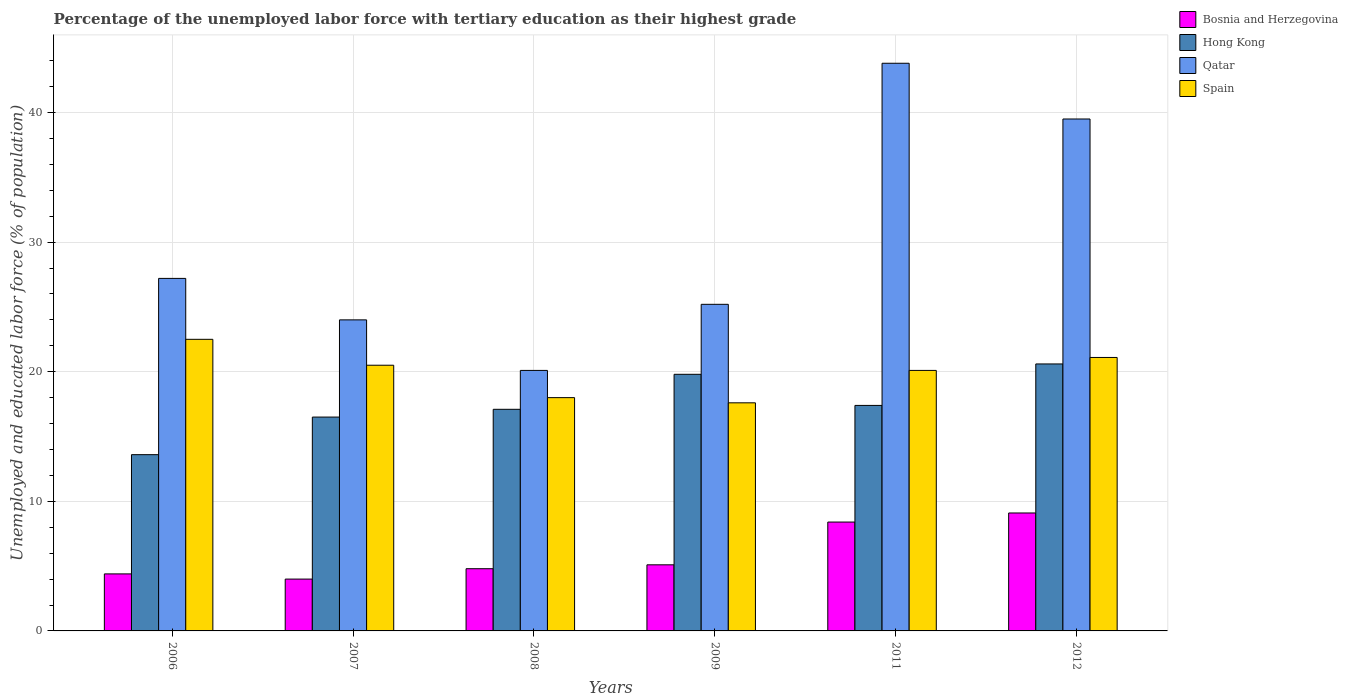How many different coloured bars are there?
Make the answer very short. 4. How many groups of bars are there?
Give a very brief answer. 6. Are the number of bars per tick equal to the number of legend labels?
Your answer should be very brief. Yes. What is the label of the 1st group of bars from the left?
Offer a terse response. 2006. In how many cases, is the number of bars for a given year not equal to the number of legend labels?
Ensure brevity in your answer.  0. What is the percentage of the unemployed labor force with tertiary education in Bosnia and Herzegovina in 2007?
Make the answer very short. 4. Across all years, what is the maximum percentage of the unemployed labor force with tertiary education in Bosnia and Herzegovina?
Ensure brevity in your answer.  9.1. Across all years, what is the minimum percentage of the unemployed labor force with tertiary education in Hong Kong?
Offer a terse response. 13.6. In which year was the percentage of the unemployed labor force with tertiary education in Hong Kong minimum?
Make the answer very short. 2006. What is the total percentage of the unemployed labor force with tertiary education in Qatar in the graph?
Ensure brevity in your answer.  179.8. What is the difference between the percentage of the unemployed labor force with tertiary education in Hong Kong in 2006 and that in 2008?
Your answer should be compact. -3.5. What is the difference between the percentage of the unemployed labor force with tertiary education in Spain in 2009 and the percentage of the unemployed labor force with tertiary education in Qatar in 2006?
Offer a very short reply. -9.6. What is the average percentage of the unemployed labor force with tertiary education in Bosnia and Herzegovina per year?
Your answer should be compact. 5.97. In the year 2012, what is the difference between the percentage of the unemployed labor force with tertiary education in Hong Kong and percentage of the unemployed labor force with tertiary education in Bosnia and Herzegovina?
Make the answer very short. 11.5. In how many years, is the percentage of the unemployed labor force with tertiary education in Qatar greater than 30 %?
Your answer should be compact. 2. What is the ratio of the percentage of the unemployed labor force with tertiary education in Bosnia and Herzegovina in 2006 to that in 2011?
Give a very brief answer. 0.52. Is the difference between the percentage of the unemployed labor force with tertiary education in Hong Kong in 2006 and 2007 greater than the difference between the percentage of the unemployed labor force with tertiary education in Bosnia and Herzegovina in 2006 and 2007?
Give a very brief answer. No. What is the difference between the highest and the second highest percentage of the unemployed labor force with tertiary education in Qatar?
Make the answer very short. 4.3. What is the difference between the highest and the lowest percentage of the unemployed labor force with tertiary education in Bosnia and Herzegovina?
Provide a succinct answer. 5.1. What does the 3rd bar from the left in 2012 represents?
Your answer should be very brief. Qatar. What does the 4th bar from the right in 2012 represents?
Ensure brevity in your answer.  Bosnia and Herzegovina. Is it the case that in every year, the sum of the percentage of the unemployed labor force with tertiary education in Bosnia and Herzegovina and percentage of the unemployed labor force with tertiary education in Qatar is greater than the percentage of the unemployed labor force with tertiary education in Spain?
Make the answer very short. Yes. Are all the bars in the graph horizontal?
Make the answer very short. No. How many years are there in the graph?
Offer a very short reply. 6. What is the difference between two consecutive major ticks on the Y-axis?
Ensure brevity in your answer.  10. Are the values on the major ticks of Y-axis written in scientific E-notation?
Give a very brief answer. No. Does the graph contain any zero values?
Your answer should be very brief. No. Does the graph contain grids?
Offer a very short reply. Yes. What is the title of the graph?
Offer a terse response. Percentage of the unemployed labor force with tertiary education as their highest grade. Does "Belarus" appear as one of the legend labels in the graph?
Your answer should be very brief. No. What is the label or title of the X-axis?
Keep it short and to the point. Years. What is the label or title of the Y-axis?
Your answer should be compact. Unemployed and educated labor force (% of population). What is the Unemployed and educated labor force (% of population) of Bosnia and Herzegovina in 2006?
Your answer should be compact. 4.4. What is the Unemployed and educated labor force (% of population) of Hong Kong in 2006?
Provide a short and direct response. 13.6. What is the Unemployed and educated labor force (% of population) of Qatar in 2006?
Offer a terse response. 27.2. What is the Unemployed and educated labor force (% of population) of Spain in 2006?
Your answer should be very brief. 22.5. What is the Unemployed and educated labor force (% of population) of Qatar in 2007?
Give a very brief answer. 24. What is the Unemployed and educated labor force (% of population) of Spain in 2007?
Keep it short and to the point. 20.5. What is the Unemployed and educated labor force (% of population) in Bosnia and Herzegovina in 2008?
Ensure brevity in your answer.  4.8. What is the Unemployed and educated labor force (% of population) of Hong Kong in 2008?
Keep it short and to the point. 17.1. What is the Unemployed and educated labor force (% of population) in Qatar in 2008?
Provide a short and direct response. 20.1. What is the Unemployed and educated labor force (% of population) of Spain in 2008?
Provide a short and direct response. 18. What is the Unemployed and educated labor force (% of population) of Bosnia and Herzegovina in 2009?
Give a very brief answer. 5.1. What is the Unemployed and educated labor force (% of population) of Hong Kong in 2009?
Your answer should be compact. 19.8. What is the Unemployed and educated labor force (% of population) of Qatar in 2009?
Ensure brevity in your answer.  25.2. What is the Unemployed and educated labor force (% of population) of Spain in 2009?
Provide a succinct answer. 17.6. What is the Unemployed and educated labor force (% of population) in Bosnia and Herzegovina in 2011?
Ensure brevity in your answer.  8.4. What is the Unemployed and educated labor force (% of population) of Hong Kong in 2011?
Provide a succinct answer. 17.4. What is the Unemployed and educated labor force (% of population) in Qatar in 2011?
Your answer should be very brief. 43.8. What is the Unemployed and educated labor force (% of population) of Spain in 2011?
Offer a terse response. 20.1. What is the Unemployed and educated labor force (% of population) of Bosnia and Herzegovina in 2012?
Your response must be concise. 9.1. What is the Unemployed and educated labor force (% of population) in Hong Kong in 2012?
Provide a short and direct response. 20.6. What is the Unemployed and educated labor force (% of population) of Qatar in 2012?
Provide a succinct answer. 39.5. What is the Unemployed and educated labor force (% of population) in Spain in 2012?
Offer a very short reply. 21.1. Across all years, what is the maximum Unemployed and educated labor force (% of population) of Bosnia and Herzegovina?
Your answer should be very brief. 9.1. Across all years, what is the maximum Unemployed and educated labor force (% of population) of Hong Kong?
Your answer should be compact. 20.6. Across all years, what is the maximum Unemployed and educated labor force (% of population) of Qatar?
Make the answer very short. 43.8. Across all years, what is the maximum Unemployed and educated labor force (% of population) in Spain?
Give a very brief answer. 22.5. Across all years, what is the minimum Unemployed and educated labor force (% of population) of Bosnia and Herzegovina?
Provide a succinct answer. 4. Across all years, what is the minimum Unemployed and educated labor force (% of population) of Hong Kong?
Give a very brief answer. 13.6. Across all years, what is the minimum Unemployed and educated labor force (% of population) of Qatar?
Provide a short and direct response. 20.1. Across all years, what is the minimum Unemployed and educated labor force (% of population) of Spain?
Give a very brief answer. 17.6. What is the total Unemployed and educated labor force (% of population) in Bosnia and Herzegovina in the graph?
Give a very brief answer. 35.8. What is the total Unemployed and educated labor force (% of population) in Hong Kong in the graph?
Your answer should be very brief. 105. What is the total Unemployed and educated labor force (% of population) of Qatar in the graph?
Offer a very short reply. 179.8. What is the total Unemployed and educated labor force (% of population) in Spain in the graph?
Provide a succinct answer. 119.8. What is the difference between the Unemployed and educated labor force (% of population) in Qatar in 2006 and that in 2007?
Make the answer very short. 3.2. What is the difference between the Unemployed and educated labor force (% of population) in Spain in 2006 and that in 2007?
Ensure brevity in your answer.  2. What is the difference between the Unemployed and educated labor force (% of population) of Bosnia and Herzegovina in 2006 and that in 2008?
Provide a short and direct response. -0.4. What is the difference between the Unemployed and educated labor force (% of population) of Bosnia and Herzegovina in 2006 and that in 2011?
Your answer should be compact. -4. What is the difference between the Unemployed and educated labor force (% of population) in Qatar in 2006 and that in 2011?
Provide a succinct answer. -16.6. What is the difference between the Unemployed and educated labor force (% of population) in Hong Kong in 2006 and that in 2012?
Offer a very short reply. -7. What is the difference between the Unemployed and educated labor force (% of population) in Qatar in 2006 and that in 2012?
Your answer should be very brief. -12.3. What is the difference between the Unemployed and educated labor force (% of population) in Spain in 2006 and that in 2012?
Your answer should be compact. 1.4. What is the difference between the Unemployed and educated labor force (% of population) in Spain in 2007 and that in 2008?
Your answer should be compact. 2.5. What is the difference between the Unemployed and educated labor force (% of population) of Bosnia and Herzegovina in 2007 and that in 2009?
Provide a succinct answer. -1.1. What is the difference between the Unemployed and educated labor force (% of population) in Hong Kong in 2007 and that in 2009?
Give a very brief answer. -3.3. What is the difference between the Unemployed and educated labor force (% of population) in Qatar in 2007 and that in 2009?
Provide a succinct answer. -1.2. What is the difference between the Unemployed and educated labor force (% of population) of Spain in 2007 and that in 2009?
Your response must be concise. 2.9. What is the difference between the Unemployed and educated labor force (% of population) of Qatar in 2007 and that in 2011?
Your response must be concise. -19.8. What is the difference between the Unemployed and educated labor force (% of population) of Spain in 2007 and that in 2011?
Your answer should be very brief. 0.4. What is the difference between the Unemployed and educated labor force (% of population) in Bosnia and Herzegovina in 2007 and that in 2012?
Provide a short and direct response. -5.1. What is the difference between the Unemployed and educated labor force (% of population) in Hong Kong in 2007 and that in 2012?
Give a very brief answer. -4.1. What is the difference between the Unemployed and educated labor force (% of population) in Qatar in 2007 and that in 2012?
Your answer should be compact. -15.5. What is the difference between the Unemployed and educated labor force (% of population) of Bosnia and Herzegovina in 2008 and that in 2009?
Your answer should be very brief. -0.3. What is the difference between the Unemployed and educated labor force (% of population) in Hong Kong in 2008 and that in 2009?
Your response must be concise. -2.7. What is the difference between the Unemployed and educated labor force (% of population) of Hong Kong in 2008 and that in 2011?
Give a very brief answer. -0.3. What is the difference between the Unemployed and educated labor force (% of population) in Qatar in 2008 and that in 2011?
Your response must be concise. -23.7. What is the difference between the Unemployed and educated labor force (% of population) in Bosnia and Herzegovina in 2008 and that in 2012?
Give a very brief answer. -4.3. What is the difference between the Unemployed and educated labor force (% of population) in Hong Kong in 2008 and that in 2012?
Make the answer very short. -3.5. What is the difference between the Unemployed and educated labor force (% of population) of Qatar in 2008 and that in 2012?
Your answer should be compact. -19.4. What is the difference between the Unemployed and educated labor force (% of population) of Spain in 2008 and that in 2012?
Ensure brevity in your answer.  -3.1. What is the difference between the Unemployed and educated labor force (% of population) of Qatar in 2009 and that in 2011?
Provide a succinct answer. -18.6. What is the difference between the Unemployed and educated labor force (% of population) of Bosnia and Herzegovina in 2009 and that in 2012?
Give a very brief answer. -4. What is the difference between the Unemployed and educated labor force (% of population) in Hong Kong in 2009 and that in 2012?
Offer a terse response. -0.8. What is the difference between the Unemployed and educated labor force (% of population) in Qatar in 2009 and that in 2012?
Offer a very short reply. -14.3. What is the difference between the Unemployed and educated labor force (% of population) of Hong Kong in 2011 and that in 2012?
Keep it short and to the point. -3.2. What is the difference between the Unemployed and educated labor force (% of population) of Qatar in 2011 and that in 2012?
Make the answer very short. 4.3. What is the difference between the Unemployed and educated labor force (% of population) in Spain in 2011 and that in 2012?
Your response must be concise. -1. What is the difference between the Unemployed and educated labor force (% of population) of Bosnia and Herzegovina in 2006 and the Unemployed and educated labor force (% of population) of Hong Kong in 2007?
Offer a terse response. -12.1. What is the difference between the Unemployed and educated labor force (% of population) in Bosnia and Herzegovina in 2006 and the Unemployed and educated labor force (% of population) in Qatar in 2007?
Ensure brevity in your answer.  -19.6. What is the difference between the Unemployed and educated labor force (% of population) of Bosnia and Herzegovina in 2006 and the Unemployed and educated labor force (% of population) of Spain in 2007?
Your answer should be compact. -16.1. What is the difference between the Unemployed and educated labor force (% of population) of Hong Kong in 2006 and the Unemployed and educated labor force (% of population) of Qatar in 2007?
Your answer should be very brief. -10.4. What is the difference between the Unemployed and educated labor force (% of population) of Hong Kong in 2006 and the Unemployed and educated labor force (% of population) of Spain in 2007?
Ensure brevity in your answer.  -6.9. What is the difference between the Unemployed and educated labor force (% of population) in Qatar in 2006 and the Unemployed and educated labor force (% of population) in Spain in 2007?
Offer a very short reply. 6.7. What is the difference between the Unemployed and educated labor force (% of population) in Bosnia and Herzegovina in 2006 and the Unemployed and educated labor force (% of population) in Qatar in 2008?
Offer a very short reply. -15.7. What is the difference between the Unemployed and educated labor force (% of population) in Bosnia and Herzegovina in 2006 and the Unemployed and educated labor force (% of population) in Hong Kong in 2009?
Provide a succinct answer. -15.4. What is the difference between the Unemployed and educated labor force (% of population) in Bosnia and Herzegovina in 2006 and the Unemployed and educated labor force (% of population) in Qatar in 2009?
Provide a short and direct response. -20.8. What is the difference between the Unemployed and educated labor force (% of population) of Hong Kong in 2006 and the Unemployed and educated labor force (% of population) of Qatar in 2009?
Your answer should be very brief. -11.6. What is the difference between the Unemployed and educated labor force (% of population) in Qatar in 2006 and the Unemployed and educated labor force (% of population) in Spain in 2009?
Provide a succinct answer. 9.6. What is the difference between the Unemployed and educated labor force (% of population) in Bosnia and Herzegovina in 2006 and the Unemployed and educated labor force (% of population) in Qatar in 2011?
Keep it short and to the point. -39.4. What is the difference between the Unemployed and educated labor force (% of population) in Bosnia and Herzegovina in 2006 and the Unemployed and educated labor force (% of population) in Spain in 2011?
Your response must be concise. -15.7. What is the difference between the Unemployed and educated labor force (% of population) in Hong Kong in 2006 and the Unemployed and educated labor force (% of population) in Qatar in 2011?
Provide a short and direct response. -30.2. What is the difference between the Unemployed and educated labor force (% of population) in Hong Kong in 2006 and the Unemployed and educated labor force (% of population) in Spain in 2011?
Ensure brevity in your answer.  -6.5. What is the difference between the Unemployed and educated labor force (% of population) of Bosnia and Herzegovina in 2006 and the Unemployed and educated labor force (% of population) of Hong Kong in 2012?
Ensure brevity in your answer.  -16.2. What is the difference between the Unemployed and educated labor force (% of population) of Bosnia and Herzegovina in 2006 and the Unemployed and educated labor force (% of population) of Qatar in 2012?
Offer a terse response. -35.1. What is the difference between the Unemployed and educated labor force (% of population) in Bosnia and Herzegovina in 2006 and the Unemployed and educated labor force (% of population) in Spain in 2012?
Offer a terse response. -16.7. What is the difference between the Unemployed and educated labor force (% of population) in Hong Kong in 2006 and the Unemployed and educated labor force (% of population) in Qatar in 2012?
Give a very brief answer. -25.9. What is the difference between the Unemployed and educated labor force (% of population) in Hong Kong in 2006 and the Unemployed and educated labor force (% of population) in Spain in 2012?
Provide a short and direct response. -7.5. What is the difference between the Unemployed and educated labor force (% of population) in Bosnia and Herzegovina in 2007 and the Unemployed and educated labor force (% of population) in Hong Kong in 2008?
Give a very brief answer. -13.1. What is the difference between the Unemployed and educated labor force (% of population) of Bosnia and Herzegovina in 2007 and the Unemployed and educated labor force (% of population) of Qatar in 2008?
Ensure brevity in your answer.  -16.1. What is the difference between the Unemployed and educated labor force (% of population) of Bosnia and Herzegovina in 2007 and the Unemployed and educated labor force (% of population) of Spain in 2008?
Keep it short and to the point. -14. What is the difference between the Unemployed and educated labor force (% of population) of Hong Kong in 2007 and the Unemployed and educated labor force (% of population) of Spain in 2008?
Your answer should be compact. -1.5. What is the difference between the Unemployed and educated labor force (% of population) of Bosnia and Herzegovina in 2007 and the Unemployed and educated labor force (% of population) of Hong Kong in 2009?
Your response must be concise. -15.8. What is the difference between the Unemployed and educated labor force (% of population) of Bosnia and Herzegovina in 2007 and the Unemployed and educated labor force (% of population) of Qatar in 2009?
Provide a short and direct response. -21.2. What is the difference between the Unemployed and educated labor force (% of population) in Bosnia and Herzegovina in 2007 and the Unemployed and educated labor force (% of population) in Spain in 2009?
Keep it short and to the point. -13.6. What is the difference between the Unemployed and educated labor force (% of population) in Hong Kong in 2007 and the Unemployed and educated labor force (% of population) in Spain in 2009?
Your response must be concise. -1.1. What is the difference between the Unemployed and educated labor force (% of population) of Qatar in 2007 and the Unemployed and educated labor force (% of population) of Spain in 2009?
Provide a succinct answer. 6.4. What is the difference between the Unemployed and educated labor force (% of population) of Bosnia and Herzegovina in 2007 and the Unemployed and educated labor force (% of population) of Hong Kong in 2011?
Your answer should be compact. -13.4. What is the difference between the Unemployed and educated labor force (% of population) of Bosnia and Herzegovina in 2007 and the Unemployed and educated labor force (% of population) of Qatar in 2011?
Provide a short and direct response. -39.8. What is the difference between the Unemployed and educated labor force (% of population) of Bosnia and Herzegovina in 2007 and the Unemployed and educated labor force (% of population) of Spain in 2011?
Provide a short and direct response. -16.1. What is the difference between the Unemployed and educated labor force (% of population) in Hong Kong in 2007 and the Unemployed and educated labor force (% of population) in Qatar in 2011?
Offer a very short reply. -27.3. What is the difference between the Unemployed and educated labor force (% of population) of Qatar in 2007 and the Unemployed and educated labor force (% of population) of Spain in 2011?
Keep it short and to the point. 3.9. What is the difference between the Unemployed and educated labor force (% of population) of Bosnia and Herzegovina in 2007 and the Unemployed and educated labor force (% of population) of Hong Kong in 2012?
Your response must be concise. -16.6. What is the difference between the Unemployed and educated labor force (% of population) in Bosnia and Herzegovina in 2007 and the Unemployed and educated labor force (% of population) in Qatar in 2012?
Give a very brief answer. -35.5. What is the difference between the Unemployed and educated labor force (% of population) of Bosnia and Herzegovina in 2007 and the Unemployed and educated labor force (% of population) of Spain in 2012?
Make the answer very short. -17.1. What is the difference between the Unemployed and educated labor force (% of population) in Hong Kong in 2007 and the Unemployed and educated labor force (% of population) in Qatar in 2012?
Your response must be concise. -23. What is the difference between the Unemployed and educated labor force (% of population) of Hong Kong in 2007 and the Unemployed and educated labor force (% of population) of Spain in 2012?
Keep it short and to the point. -4.6. What is the difference between the Unemployed and educated labor force (% of population) of Qatar in 2007 and the Unemployed and educated labor force (% of population) of Spain in 2012?
Offer a very short reply. 2.9. What is the difference between the Unemployed and educated labor force (% of population) in Bosnia and Herzegovina in 2008 and the Unemployed and educated labor force (% of population) in Qatar in 2009?
Provide a short and direct response. -20.4. What is the difference between the Unemployed and educated labor force (% of population) in Hong Kong in 2008 and the Unemployed and educated labor force (% of population) in Qatar in 2009?
Offer a very short reply. -8.1. What is the difference between the Unemployed and educated labor force (% of population) in Bosnia and Herzegovina in 2008 and the Unemployed and educated labor force (% of population) in Qatar in 2011?
Your response must be concise. -39. What is the difference between the Unemployed and educated labor force (% of population) of Bosnia and Herzegovina in 2008 and the Unemployed and educated labor force (% of population) of Spain in 2011?
Your response must be concise. -15.3. What is the difference between the Unemployed and educated labor force (% of population) in Hong Kong in 2008 and the Unemployed and educated labor force (% of population) in Qatar in 2011?
Make the answer very short. -26.7. What is the difference between the Unemployed and educated labor force (% of population) of Qatar in 2008 and the Unemployed and educated labor force (% of population) of Spain in 2011?
Your response must be concise. 0. What is the difference between the Unemployed and educated labor force (% of population) of Bosnia and Herzegovina in 2008 and the Unemployed and educated labor force (% of population) of Hong Kong in 2012?
Keep it short and to the point. -15.8. What is the difference between the Unemployed and educated labor force (% of population) in Bosnia and Herzegovina in 2008 and the Unemployed and educated labor force (% of population) in Qatar in 2012?
Your response must be concise. -34.7. What is the difference between the Unemployed and educated labor force (% of population) in Bosnia and Herzegovina in 2008 and the Unemployed and educated labor force (% of population) in Spain in 2012?
Your response must be concise. -16.3. What is the difference between the Unemployed and educated labor force (% of population) in Hong Kong in 2008 and the Unemployed and educated labor force (% of population) in Qatar in 2012?
Offer a terse response. -22.4. What is the difference between the Unemployed and educated labor force (% of population) of Qatar in 2008 and the Unemployed and educated labor force (% of population) of Spain in 2012?
Give a very brief answer. -1. What is the difference between the Unemployed and educated labor force (% of population) in Bosnia and Herzegovina in 2009 and the Unemployed and educated labor force (% of population) in Hong Kong in 2011?
Provide a succinct answer. -12.3. What is the difference between the Unemployed and educated labor force (% of population) in Bosnia and Herzegovina in 2009 and the Unemployed and educated labor force (% of population) in Qatar in 2011?
Offer a very short reply. -38.7. What is the difference between the Unemployed and educated labor force (% of population) of Bosnia and Herzegovina in 2009 and the Unemployed and educated labor force (% of population) of Spain in 2011?
Keep it short and to the point. -15. What is the difference between the Unemployed and educated labor force (% of population) in Qatar in 2009 and the Unemployed and educated labor force (% of population) in Spain in 2011?
Make the answer very short. 5.1. What is the difference between the Unemployed and educated labor force (% of population) of Bosnia and Herzegovina in 2009 and the Unemployed and educated labor force (% of population) of Hong Kong in 2012?
Offer a terse response. -15.5. What is the difference between the Unemployed and educated labor force (% of population) of Bosnia and Herzegovina in 2009 and the Unemployed and educated labor force (% of population) of Qatar in 2012?
Your response must be concise. -34.4. What is the difference between the Unemployed and educated labor force (% of population) in Hong Kong in 2009 and the Unemployed and educated labor force (% of population) in Qatar in 2012?
Provide a succinct answer. -19.7. What is the difference between the Unemployed and educated labor force (% of population) in Hong Kong in 2009 and the Unemployed and educated labor force (% of population) in Spain in 2012?
Keep it short and to the point. -1.3. What is the difference between the Unemployed and educated labor force (% of population) in Qatar in 2009 and the Unemployed and educated labor force (% of population) in Spain in 2012?
Give a very brief answer. 4.1. What is the difference between the Unemployed and educated labor force (% of population) in Bosnia and Herzegovina in 2011 and the Unemployed and educated labor force (% of population) in Hong Kong in 2012?
Ensure brevity in your answer.  -12.2. What is the difference between the Unemployed and educated labor force (% of population) in Bosnia and Herzegovina in 2011 and the Unemployed and educated labor force (% of population) in Qatar in 2012?
Your answer should be compact. -31.1. What is the difference between the Unemployed and educated labor force (% of population) of Hong Kong in 2011 and the Unemployed and educated labor force (% of population) of Qatar in 2012?
Your answer should be compact. -22.1. What is the difference between the Unemployed and educated labor force (% of population) in Qatar in 2011 and the Unemployed and educated labor force (% of population) in Spain in 2012?
Your answer should be very brief. 22.7. What is the average Unemployed and educated labor force (% of population) in Bosnia and Herzegovina per year?
Offer a terse response. 5.97. What is the average Unemployed and educated labor force (% of population) in Hong Kong per year?
Your response must be concise. 17.5. What is the average Unemployed and educated labor force (% of population) of Qatar per year?
Make the answer very short. 29.97. What is the average Unemployed and educated labor force (% of population) in Spain per year?
Your answer should be very brief. 19.97. In the year 2006, what is the difference between the Unemployed and educated labor force (% of population) of Bosnia and Herzegovina and Unemployed and educated labor force (% of population) of Hong Kong?
Make the answer very short. -9.2. In the year 2006, what is the difference between the Unemployed and educated labor force (% of population) of Bosnia and Herzegovina and Unemployed and educated labor force (% of population) of Qatar?
Your answer should be compact. -22.8. In the year 2006, what is the difference between the Unemployed and educated labor force (% of population) in Bosnia and Herzegovina and Unemployed and educated labor force (% of population) in Spain?
Provide a succinct answer. -18.1. In the year 2006, what is the difference between the Unemployed and educated labor force (% of population) of Hong Kong and Unemployed and educated labor force (% of population) of Spain?
Your answer should be very brief. -8.9. In the year 2006, what is the difference between the Unemployed and educated labor force (% of population) in Qatar and Unemployed and educated labor force (% of population) in Spain?
Provide a short and direct response. 4.7. In the year 2007, what is the difference between the Unemployed and educated labor force (% of population) of Bosnia and Herzegovina and Unemployed and educated labor force (% of population) of Qatar?
Provide a short and direct response. -20. In the year 2007, what is the difference between the Unemployed and educated labor force (% of population) of Bosnia and Herzegovina and Unemployed and educated labor force (% of population) of Spain?
Ensure brevity in your answer.  -16.5. In the year 2007, what is the difference between the Unemployed and educated labor force (% of population) of Hong Kong and Unemployed and educated labor force (% of population) of Qatar?
Keep it short and to the point. -7.5. In the year 2007, what is the difference between the Unemployed and educated labor force (% of population) in Hong Kong and Unemployed and educated labor force (% of population) in Spain?
Your answer should be very brief. -4. In the year 2007, what is the difference between the Unemployed and educated labor force (% of population) in Qatar and Unemployed and educated labor force (% of population) in Spain?
Your answer should be compact. 3.5. In the year 2008, what is the difference between the Unemployed and educated labor force (% of population) of Bosnia and Herzegovina and Unemployed and educated labor force (% of population) of Qatar?
Offer a very short reply. -15.3. In the year 2008, what is the difference between the Unemployed and educated labor force (% of population) of Hong Kong and Unemployed and educated labor force (% of population) of Qatar?
Give a very brief answer. -3. In the year 2008, what is the difference between the Unemployed and educated labor force (% of population) in Hong Kong and Unemployed and educated labor force (% of population) in Spain?
Offer a very short reply. -0.9. In the year 2008, what is the difference between the Unemployed and educated labor force (% of population) of Qatar and Unemployed and educated labor force (% of population) of Spain?
Your answer should be very brief. 2.1. In the year 2009, what is the difference between the Unemployed and educated labor force (% of population) in Bosnia and Herzegovina and Unemployed and educated labor force (% of population) in Hong Kong?
Your answer should be very brief. -14.7. In the year 2009, what is the difference between the Unemployed and educated labor force (% of population) of Bosnia and Herzegovina and Unemployed and educated labor force (% of population) of Qatar?
Give a very brief answer. -20.1. In the year 2009, what is the difference between the Unemployed and educated labor force (% of population) in Hong Kong and Unemployed and educated labor force (% of population) in Spain?
Provide a short and direct response. 2.2. In the year 2009, what is the difference between the Unemployed and educated labor force (% of population) of Qatar and Unemployed and educated labor force (% of population) of Spain?
Offer a very short reply. 7.6. In the year 2011, what is the difference between the Unemployed and educated labor force (% of population) in Bosnia and Herzegovina and Unemployed and educated labor force (% of population) in Qatar?
Keep it short and to the point. -35.4. In the year 2011, what is the difference between the Unemployed and educated labor force (% of population) of Bosnia and Herzegovina and Unemployed and educated labor force (% of population) of Spain?
Ensure brevity in your answer.  -11.7. In the year 2011, what is the difference between the Unemployed and educated labor force (% of population) of Hong Kong and Unemployed and educated labor force (% of population) of Qatar?
Your answer should be very brief. -26.4. In the year 2011, what is the difference between the Unemployed and educated labor force (% of population) of Qatar and Unemployed and educated labor force (% of population) of Spain?
Your response must be concise. 23.7. In the year 2012, what is the difference between the Unemployed and educated labor force (% of population) of Bosnia and Herzegovina and Unemployed and educated labor force (% of population) of Hong Kong?
Your response must be concise. -11.5. In the year 2012, what is the difference between the Unemployed and educated labor force (% of population) of Bosnia and Herzegovina and Unemployed and educated labor force (% of population) of Qatar?
Provide a succinct answer. -30.4. In the year 2012, what is the difference between the Unemployed and educated labor force (% of population) in Bosnia and Herzegovina and Unemployed and educated labor force (% of population) in Spain?
Offer a very short reply. -12. In the year 2012, what is the difference between the Unemployed and educated labor force (% of population) in Hong Kong and Unemployed and educated labor force (% of population) in Qatar?
Provide a succinct answer. -18.9. In the year 2012, what is the difference between the Unemployed and educated labor force (% of population) in Hong Kong and Unemployed and educated labor force (% of population) in Spain?
Your response must be concise. -0.5. What is the ratio of the Unemployed and educated labor force (% of population) of Hong Kong in 2006 to that in 2007?
Your answer should be compact. 0.82. What is the ratio of the Unemployed and educated labor force (% of population) in Qatar in 2006 to that in 2007?
Ensure brevity in your answer.  1.13. What is the ratio of the Unemployed and educated labor force (% of population) in Spain in 2006 to that in 2007?
Ensure brevity in your answer.  1.1. What is the ratio of the Unemployed and educated labor force (% of population) in Hong Kong in 2006 to that in 2008?
Keep it short and to the point. 0.8. What is the ratio of the Unemployed and educated labor force (% of population) in Qatar in 2006 to that in 2008?
Make the answer very short. 1.35. What is the ratio of the Unemployed and educated labor force (% of population) of Spain in 2006 to that in 2008?
Ensure brevity in your answer.  1.25. What is the ratio of the Unemployed and educated labor force (% of population) of Bosnia and Herzegovina in 2006 to that in 2009?
Ensure brevity in your answer.  0.86. What is the ratio of the Unemployed and educated labor force (% of population) of Hong Kong in 2006 to that in 2009?
Provide a succinct answer. 0.69. What is the ratio of the Unemployed and educated labor force (% of population) in Qatar in 2006 to that in 2009?
Offer a terse response. 1.08. What is the ratio of the Unemployed and educated labor force (% of population) of Spain in 2006 to that in 2009?
Keep it short and to the point. 1.28. What is the ratio of the Unemployed and educated labor force (% of population) in Bosnia and Herzegovina in 2006 to that in 2011?
Provide a succinct answer. 0.52. What is the ratio of the Unemployed and educated labor force (% of population) in Hong Kong in 2006 to that in 2011?
Provide a succinct answer. 0.78. What is the ratio of the Unemployed and educated labor force (% of population) in Qatar in 2006 to that in 2011?
Ensure brevity in your answer.  0.62. What is the ratio of the Unemployed and educated labor force (% of population) of Spain in 2006 to that in 2011?
Your response must be concise. 1.12. What is the ratio of the Unemployed and educated labor force (% of population) of Bosnia and Herzegovina in 2006 to that in 2012?
Make the answer very short. 0.48. What is the ratio of the Unemployed and educated labor force (% of population) in Hong Kong in 2006 to that in 2012?
Keep it short and to the point. 0.66. What is the ratio of the Unemployed and educated labor force (% of population) in Qatar in 2006 to that in 2012?
Provide a short and direct response. 0.69. What is the ratio of the Unemployed and educated labor force (% of population) in Spain in 2006 to that in 2012?
Your answer should be very brief. 1.07. What is the ratio of the Unemployed and educated labor force (% of population) in Bosnia and Herzegovina in 2007 to that in 2008?
Your answer should be very brief. 0.83. What is the ratio of the Unemployed and educated labor force (% of population) of Hong Kong in 2007 to that in 2008?
Offer a very short reply. 0.96. What is the ratio of the Unemployed and educated labor force (% of population) of Qatar in 2007 to that in 2008?
Offer a very short reply. 1.19. What is the ratio of the Unemployed and educated labor force (% of population) in Spain in 2007 to that in 2008?
Give a very brief answer. 1.14. What is the ratio of the Unemployed and educated labor force (% of population) in Bosnia and Herzegovina in 2007 to that in 2009?
Give a very brief answer. 0.78. What is the ratio of the Unemployed and educated labor force (% of population) of Hong Kong in 2007 to that in 2009?
Offer a very short reply. 0.83. What is the ratio of the Unemployed and educated labor force (% of population) of Qatar in 2007 to that in 2009?
Offer a terse response. 0.95. What is the ratio of the Unemployed and educated labor force (% of population) in Spain in 2007 to that in 2009?
Give a very brief answer. 1.16. What is the ratio of the Unemployed and educated labor force (% of population) in Bosnia and Herzegovina in 2007 to that in 2011?
Your response must be concise. 0.48. What is the ratio of the Unemployed and educated labor force (% of population) in Hong Kong in 2007 to that in 2011?
Your answer should be compact. 0.95. What is the ratio of the Unemployed and educated labor force (% of population) of Qatar in 2007 to that in 2011?
Your answer should be compact. 0.55. What is the ratio of the Unemployed and educated labor force (% of population) of Spain in 2007 to that in 2011?
Give a very brief answer. 1.02. What is the ratio of the Unemployed and educated labor force (% of population) of Bosnia and Herzegovina in 2007 to that in 2012?
Your answer should be compact. 0.44. What is the ratio of the Unemployed and educated labor force (% of population) of Hong Kong in 2007 to that in 2012?
Keep it short and to the point. 0.8. What is the ratio of the Unemployed and educated labor force (% of population) in Qatar in 2007 to that in 2012?
Keep it short and to the point. 0.61. What is the ratio of the Unemployed and educated labor force (% of population) of Spain in 2007 to that in 2012?
Ensure brevity in your answer.  0.97. What is the ratio of the Unemployed and educated labor force (% of population) of Hong Kong in 2008 to that in 2009?
Your response must be concise. 0.86. What is the ratio of the Unemployed and educated labor force (% of population) in Qatar in 2008 to that in 2009?
Give a very brief answer. 0.8. What is the ratio of the Unemployed and educated labor force (% of population) in Spain in 2008 to that in 2009?
Provide a short and direct response. 1.02. What is the ratio of the Unemployed and educated labor force (% of population) of Bosnia and Herzegovina in 2008 to that in 2011?
Offer a very short reply. 0.57. What is the ratio of the Unemployed and educated labor force (% of population) in Hong Kong in 2008 to that in 2011?
Provide a succinct answer. 0.98. What is the ratio of the Unemployed and educated labor force (% of population) of Qatar in 2008 to that in 2011?
Give a very brief answer. 0.46. What is the ratio of the Unemployed and educated labor force (% of population) of Spain in 2008 to that in 2011?
Provide a succinct answer. 0.9. What is the ratio of the Unemployed and educated labor force (% of population) in Bosnia and Herzegovina in 2008 to that in 2012?
Keep it short and to the point. 0.53. What is the ratio of the Unemployed and educated labor force (% of population) of Hong Kong in 2008 to that in 2012?
Your answer should be very brief. 0.83. What is the ratio of the Unemployed and educated labor force (% of population) in Qatar in 2008 to that in 2012?
Give a very brief answer. 0.51. What is the ratio of the Unemployed and educated labor force (% of population) in Spain in 2008 to that in 2012?
Give a very brief answer. 0.85. What is the ratio of the Unemployed and educated labor force (% of population) in Bosnia and Herzegovina in 2009 to that in 2011?
Give a very brief answer. 0.61. What is the ratio of the Unemployed and educated labor force (% of population) of Hong Kong in 2009 to that in 2011?
Ensure brevity in your answer.  1.14. What is the ratio of the Unemployed and educated labor force (% of population) of Qatar in 2009 to that in 2011?
Make the answer very short. 0.58. What is the ratio of the Unemployed and educated labor force (% of population) in Spain in 2009 to that in 2011?
Your answer should be compact. 0.88. What is the ratio of the Unemployed and educated labor force (% of population) in Bosnia and Herzegovina in 2009 to that in 2012?
Keep it short and to the point. 0.56. What is the ratio of the Unemployed and educated labor force (% of population) in Hong Kong in 2009 to that in 2012?
Give a very brief answer. 0.96. What is the ratio of the Unemployed and educated labor force (% of population) in Qatar in 2009 to that in 2012?
Make the answer very short. 0.64. What is the ratio of the Unemployed and educated labor force (% of population) in Spain in 2009 to that in 2012?
Offer a terse response. 0.83. What is the ratio of the Unemployed and educated labor force (% of population) of Hong Kong in 2011 to that in 2012?
Provide a short and direct response. 0.84. What is the ratio of the Unemployed and educated labor force (% of population) of Qatar in 2011 to that in 2012?
Keep it short and to the point. 1.11. What is the ratio of the Unemployed and educated labor force (% of population) in Spain in 2011 to that in 2012?
Give a very brief answer. 0.95. What is the difference between the highest and the second highest Unemployed and educated labor force (% of population) in Bosnia and Herzegovina?
Your answer should be very brief. 0.7. What is the difference between the highest and the second highest Unemployed and educated labor force (% of population) of Qatar?
Provide a succinct answer. 4.3. What is the difference between the highest and the second highest Unemployed and educated labor force (% of population) in Spain?
Offer a terse response. 1.4. What is the difference between the highest and the lowest Unemployed and educated labor force (% of population) of Bosnia and Herzegovina?
Ensure brevity in your answer.  5.1. What is the difference between the highest and the lowest Unemployed and educated labor force (% of population) in Qatar?
Offer a very short reply. 23.7. What is the difference between the highest and the lowest Unemployed and educated labor force (% of population) in Spain?
Provide a short and direct response. 4.9. 